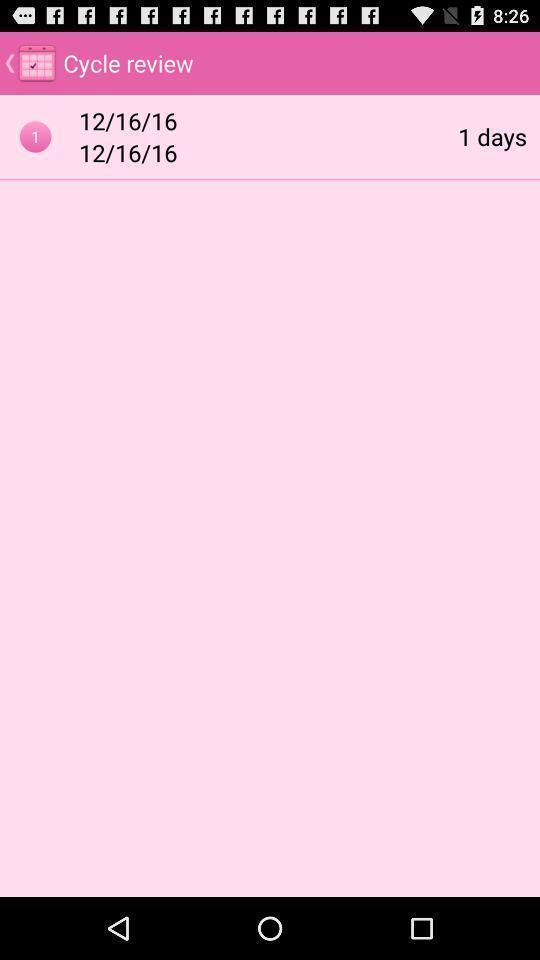What is the overall content of this screenshot? Screen shows details. 